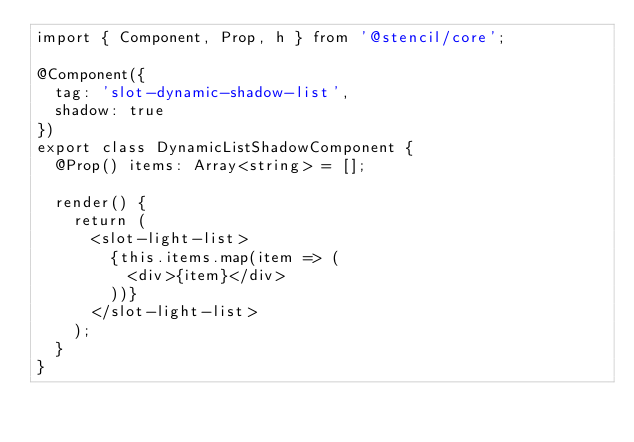<code> <loc_0><loc_0><loc_500><loc_500><_TypeScript_>import { Component, Prop, h } from '@stencil/core';

@Component({
  tag: 'slot-dynamic-shadow-list',
  shadow: true
})
export class DynamicListShadowComponent {
  @Prop() items: Array<string> = [];

  render() {
    return (
      <slot-light-list>
        {this.items.map(item => (
          <div>{item}</div>
        ))}
      </slot-light-list>
    );
  }
}
</code> 